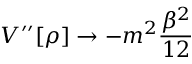<formula> <loc_0><loc_0><loc_500><loc_500>V ^ { \prime \prime } [ \rho ] \rightarrow - m ^ { 2 } \frac { \beta ^ { 2 } } { 1 2 }</formula> 